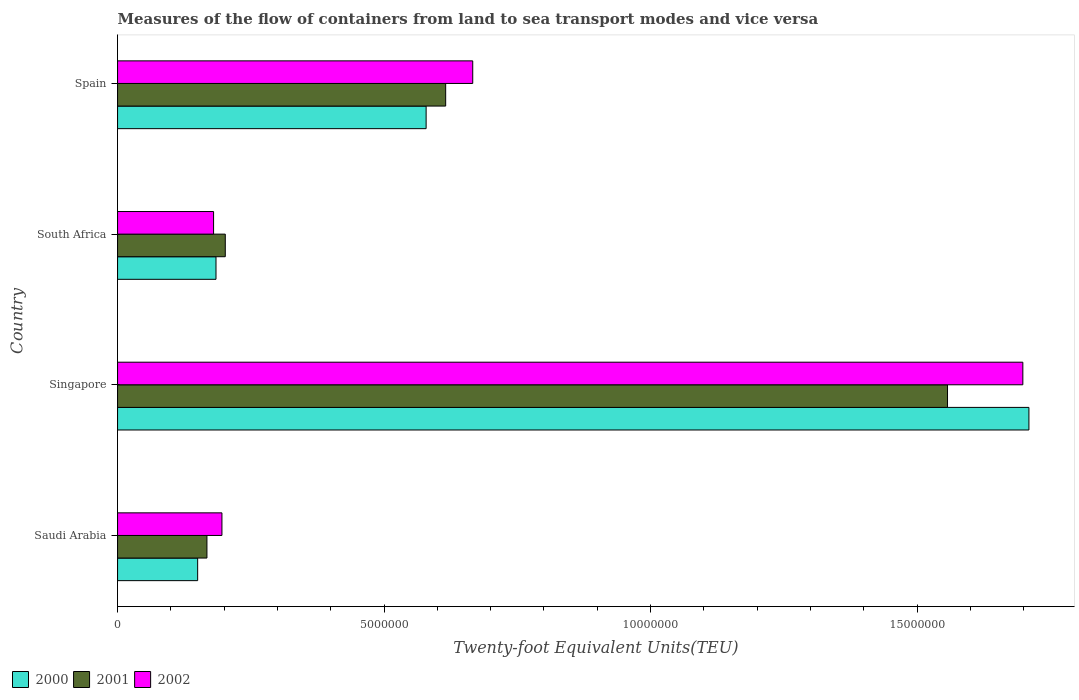How many groups of bars are there?
Make the answer very short. 4. Are the number of bars per tick equal to the number of legend labels?
Your answer should be compact. Yes. Are the number of bars on each tick of the Y-axis equal?
Give a very brief answer. Yes. How many bars are there on the 2nd tick from the top?
Your response must be concise. 3. What is the label of the 4th group of bars from the top?
Provide a succinct answer. Saudi Arabia. In how many cases, is the number of bars for a given country not equal to the number of legend labels?
Offer a terse response. 0. What is the container port traffic in 2000 in Saudi Arabia?
Provide a succinct answer. 1.50e+06. Across all countries, what is the maximum container port traffic in 2002?
Give a very brief answer. 1.70e+07. Across all countries, what is the minimum container port traffic in 2000?
Offer a terse response. 1.50e+06. In which country was the container port traffic in 2000 maximum?
Your response must be concise. Singapore. In which country was the container port traffic in 2001 minimum?
Make the answer very short. Saudi Arabia. What is the total container port traffic in 2002 in the graph?
Make the answer very short. 2.74e+07. What is the difference between the container port traffic in 2000 in Saudi Arabia and that in South Africa?
Ensure brevity in your answer.  -3.44e+05. What is the difference between the container port traffic in 2002 in Saudi Arabia and the container port traffic in 2000 in Singapore?
Keep it short and to the point. -1.51e+07. What is the average container port traffic in 2002 per country?
Your response must be concise. 6.85e+06. What is the difference between the container port traffic in 2002 and container port traffic in 2001 in Singapore?
Your response must be concise. 1.41e+06. What is the ratio of the container port traffic in 2000 in Saudi Arabia to that in South Africa?
Your answer should be very brief. 0.81. Is the container port traffic in 2002 in Singapore less than that in Spain?
Give a very brief answer. No. What is the difference between the highest and the second highest container port traffic in 2000?
Your answer should be compact. 1.13e+07. What is the difference between the highest and the lowest container port traffic in 2001?
Provide a short and direct response. 1.39e+07. In how many countries, is the container port traffic in 2002 greater than the average container port traffic in 2002 taken over all countries?
Make the answer very short. 1. Is the sum of the container port traffic in 2002 in Saudi Arabia and South Africa greater than the maximum container port traffic in 2000 across all countries?
Your response must be concise. No. What does the 3rd bar from the bottom in Spain represents?
Ensure brevity in your answer.  2002. How many bars are there?
Your answer should be very brief. 12. Does the graph contain grids?
Offer a very short reply. No. Where does the legend appear in the graph?
Your answer should be very brief. Bottom left. How many legend labels are there?
Offer a terse response. 3. How are the legend labels stacked?
Your response must be concise. Horizontal. What is the title of the graph?
Your answer should be very brief. Measures of the flow of containers from land to sea transport modes and vice versa. Does "1995" appear as one of the legend labels in the graph?
Give a very brief answer. No. What is the label or title of the X-axis?
Ensure brevity in your answer.  Twenty-foot Equivalent Units(TEU). What is the Twenty-foot Equivalent Units(TEU) of 2000 in Saudi Arabia?
Ensure brevity in your answer.  1.50e+06. What is the Twenty-foot Equivalent Units(TEU) of 2001 in Saudi Arabia?
Offer a very short reply. 1.68e+06. What is the Twenty-foot Equivalent Units(TEU) in 2002 in Saudi Arabia?
Make the answer very short. 1.96e+06. What is the Twenty-foot Equivalent Units(TEU) in 2000 in Singapore?
Give a very brief answer. 1.71e+07. What is the Twenty-foot Equivalent Units(TEU) in 2001 in Singapore?
Your answer should be compact. 1.56e+07. What is the Twenty-foot Equivalent Units(TEU) of 2002 in Singapore?
Provide a short and direct response. 1.70e+07. What is the Twenty-foot Equivalent Units(TEU) in 2000 in South Africa?
Provide a succinct answer. 1.85e+06. What is the Twenty-foot Equivalent Units(TEU) in 2001 in South Africa?
Offer a terse response. 2.02e+06. What is the Twenty-foot Equivalent Units(TEU) in 2002 in South Africa?
Ensure brevity in your answer.  1.80e+06. What is the Twenty-foot Equivalent Units(TEU) of 2000 in Spain?
Ensure brevity in your answer.  5.79e+06. What is the Twenty-foot Equivalent Units(TEU) in 2001 in Spain?
Provide a succinct answer. 6.16e+06. What is the Twenty-foot Equivalent Units(TEU) in 2002 in Spain?
Offer a terse response. 6.66e+06. Across all countries, what is the maximum Twenty-foot Equivalent Units(TEU) of 2000?
Your answer should be very brief. 1.71e+07. Across all countries, what is the maximum Twenty-foot Equivalent Units(TEU) in 2001?
Your answer should be compact. 1.56e+07. Across all countries, what is the maximum Twenty-foot Equivalent Units(TEU) of 2002?
Your answer should be compact. 1.70e+07. Across all countries, what is the minimum Twenty-foot Equivalent Units(TEU) in 2000?
Keep it short and to the point. 1.50e+06. Across all countries, what is the minimum Twenty-foot Equivalent Units(TEU) in 2001?
Provide a succinct answer. 1.68e+06. Across all countries, what is the minimum Twenty-foot Equivalent Units(TEU) in 2002?
Make the answer very short. 1.80e+06. What is the total Twenty-foot Equivalent Units(TEU) of 2000 in the graph?
Your answer should be compact. 2.62e+07. What is the total Twenty-foot Equivalent Units(TEU) in 2001 in the graph?
Ensure brevity in your answer.  2.54e+07. What is the total Twenty-foot Equivalent Units(TEU) in 2002 in the graph?
Offer a terse response. 2.74e+07. What is the difference between the Twenty-foot Equivalent Units(TEU) of 2000 in Saudi Arabia and that in Singapore?
Provide a succinct answer. -1.56e+07. What is the difference between the Twenty-foot Equivalent Units(TEU) of 2001 in Saudi Arabia and that in Singapore?
Offer a very short reply. -1.39e+07. What is the difference between the Twenty-foot Equivalent Units(TEU) in 2002 in Saudi Arabia and that in Singapore?
Your response must be concise. -1.50e+07. What is the difference between the Twenty-foot Equivalent Units(TEU) of 2000 in Saudi Arabia and that in South Africa?
Give a very brief answer. -3.44e+05. What is the difference between the Twenty-foot Equivalent Units(TEU) of 2001 in Saudi Arabia and that in South Africa?
Keep it short and to the point. -3.44e+05. What is the difference between the Twenty-foot Equivalent Units(TEU) of 2002 in Saudi Arabia and that in South Africa?
Your answer should be compact. 1.57e+05. What is the difference between the Twenty-foot Equivalent Units(TEU) in 2000 in Saudi Arabia and that in Spain?
Keep it short and to the point. -4.29e+06. What is the difference between the Twenty-foot Equivalent Units(TEU) of 2001 in Saudi Arabia and that in Spain?
Your answer should be very brief. -4.48e+06. What is the difference between the Twenty-foot Equivalent Units(TEU) of 2002 in Saudi Arabia and that in Spain?
Make the answer very short. -4.71e+06. What is the difference between the Twenty-foot Equivalent Units(TEU) in 2000 in Singapore and that in South Africa?
Offer a terse response. 1.53e+07. What is the difference between the Twenty-foot Equivalent Units(TEU) in 2001 in Singapore and that in South Africa?
Give a very brief answer. 1.36e+07. What is the difference between the Twenty-foot Equivalent Units(TEU) of 2002 in Singapore and that in South Africa?
Offer a terse response. 1.52e+07. What is the difference between the Twenty-foot Equivalent Units(TEU) in 2000 in Singapore and that in Spain?
Make the answer very short. 1.13e+07. What is the difference between the Twenty-foot Equivalent Units(TEU) in 2001 in Singapore and that in Spain?
Offer a terse response. 9.42e+06. What is the difference between the Twenty-foot Equivalent Units(TEU) of 2002 in Singapore and that in Spain?
Provide a short and direct response. 1.03e+07. What is the difference between the Twenty-foot Equivalent Units(TEU) of 2000 in South Africa and that in Spain?
Your answer should be very brief. -3.94e+06. What is the difference between the Twenty-foot Equivalent Units(TEU) in 2001 in South Africa and that in Spain?
Your answer should be very brief. -4.14e+06. What is the difference between the Twenty-foot Equivalent Units(TEU) in 2002 in South Africa and that in Spain?
Offer a terse response. -4.86e+06. What is the difference between the Twenty-foot Equivalent Units(TEU) of 2000 in Saudi Arabia and the Twenty-foot Equivalent Units(TEU) of 2001 in Singapore?
Your response must be concise. -1.41e+07. What is the difference between the Twenty-foot Equivalent Units(TEU) in 2000 in Saudi Arabia and the Twenty-foot Equivalent Units(TEU) in 2002 in Singapore?
Provide a short and direct response. -1.55e+07. What is the difference between the Twenty-foot Equivalent Units(TEU) of 2001 in Saudi Arabia and the Twenty-foot Equivalent Units(TEU) of 2002 in Singapore?
Your response must be concise. -1.53e+07. What is the difference between the Twenty-foot Equivalent Units(TEU) of 2000 in Saudi Arabia and the Twenty-foot Equivalent Units(TEU) of 2001 in South Africa?
Give a very brief answer. -5.18e+05. What is the difference between the Twenty-foot Equivalent Units(TEU) in 2000 in Saudi Arabia and the Twenty-foot Equivalent Units(TEU) in 2002 in South Africa?
Your answer should be compact. -2.99e+05. What is the difference between the Twenty-foot Equivalent Units(TEU) in 2001 in Saudi Arabia and the Twenty-foot Equivalent Units(TEU) in 2002 in South Africa?
Provide a short and direct response. -1.25e+05. What is the difference between the Twenty-foot Equivalent Units(TEU) of 2000 in Saudi Arabia and the Twenty-foot Equivalent Units(TEU) of 2001 in Spain?
Your response must be concise. -4.65e+06. What is the difference between the Twenty-foot Equivalent Units(TEU) of 2000 in Saudi Arabia and the Twenty-foot Equivalent Units(TEU) of 2002 in Spain?
Provide a succinct answer. -5.16e+06. What is the difference between the Twenty-foot Equivalent Units(TEU) of 2001 in Saudi Arabia and the Twenty-foot Equivalent Units(TEU) of 2002 in Spain?
Offer a very short reply. -4.99e+06. What is the difference between the Twenty-foot Equivalent Units(TEU) in 2000 in Singapore and the Twenty-foot Equivalent Units(TEU) in 2001 in South Africa?
Offer a terse response. 1.51e+07. What is the difference between the Twenty-foot Equivalent Units(TEU) of 2000 in Singapore and the Twenty-foot Equivalent Units(TEU) of 2002 in South Africa?
Give a very brief answer. 1.53e+07. What is the difference between the Twenty-foot Equivalent Units(TEU) in 2001 in Singapore and the Twenty-foot Equivalent Units(TEU) in 2002 in South Africa?
Your response must be concise. 1.38e+07. What is the difference between the Twenty-foot Equivalent Units(TEU) in 2000 in Singapore and the Twenty-foot Equivalent Units(TEU) in 2001 in Spain?
Your response must be concise. 1.09e+07. What is the difference between the Twenty-foot Equivalent Units(TEU) of 2000 in Singapore and the Twenty-foot Equivalent Units(TEU) of 2002 in Spain?
Ensure brevity in your answer.  1.04e+07. What is the difference between the Twenty-foot Equivalent Units(TEU) in 2001 in Singapore and the Twenty-foot Equivalent Units(TEU) in 2002 in Spain?
Provide a succinct answer. 8.91e+06. What is the difference between the Twenty-foot Equivalent Units(TEU) in 2000 in South Africa and the Twenty-foot Equivalent Units(TEU) in 2001 in Spain?
Give a very brief answer. -4.31e+06. What is the difference between the Twenty-foot Equivalent Units(TEU) of 2000 in South Africa and the Twenty-foot Equivalent Units(TEU) of 2002 in Spain?
Ensure brevity in your answer.  -4.82e+06. What is the difference between the Twenty-foot Equivalent Units(TEU) of 2001 in South Africa and the Twenty-foot Equivalent Units(TEU) of 2002 in Spain?
Give a very brief answer. -4.64e+06. What is the average Twenty-foot Equivalent Units(TEU) of 2000 per country?
Offer a very short reply. 6.56e+06. What is the average Twenty-foot Equivalent Units(TEU) of 2001 per country?
Make the answer very short. 6.36e+06. What is the average Twenty-foot Equivalent Units(TEU) of 2002 per country?
Give a very brief answer. 6.85e+06. What is the difference between the Twenty-foot Equivalent Units(TEU) of 2000 and Twenty-foot Equivalent Units(TEU) of 2001 in Saudi Arabia?
Offer a very short reply. -1.74e+05. What is the difference between the Twenty-foot Equivalent Units(TEU) of 2000 and Twenty-foot Equivalent Units(TEU) of 2002 in Saudi Arabia?
Provide a short and direct response. -4.56e+05. What is the difference between the Twenty-foot Equivalent Units(TEU) in 2001 and Twenty-foot Equivalent Units(TEU) in 2002 in Saudi Arabia?
Give a very brief answer. -2.82e+05. What is the difference between the Twenty-foot Equivalent Units(TEU) of 2000 and Twenty-foot Equivalent Units(TEU) of 2001 in Singapore?
Your answer should be compact. 1.53e+06. What is the difference between the Twenty-foot Equivalent Units(TEU) of 2000 and Twenty-foot Equivalent Units(TEU) of 2002 in Singapore?
Offer a very short reply. 1.14e+05. What is the difference between the Twenty-foot Equivalent Units(TEU) of 2001 and Twenty-foot Equivalent Units(TEU) of 2002 in Singapore?
Your response must be concise. -1.41e+06. What is the difference between the Twenty-foot Equivalent Units(TEU) of 2000 and Twenty-foot Equivalent Units(TEU) of 2001 in South Africa?
Offer a very short reply. -1.74e+05. What is the difference between the Twenty-foot Equivalent Units(TEU) of 2000 and Twenty-foot Equivalent Units(TEU) of 2002 in South Africa?
Provide a succinct answer. 4.53e+04. What is the difference between the Twenty-foot Equivalent Units(TEU) in 2001 and Twenty-foot Equivalent Units(TEU) in 2002 in South Africa?
Keep it short and to the point. 2.20e+05. What is the difference between the Twenty-foot Equivalent Units(TEU) of 2000 and Twenty-foot Equivalent Units(TEU) of 2001 in Spain?
Your response must be concise. -3.67e+05. What is the difference between the Twenty-foot Equivalent Units(TEU) of 2000 and Twenty-foot Equivalent Units(TEU) of 2002 in Spain?
Offer a terse response. -8.74e+05. What is the difference between the Twenty-foot Equivalent Units(TEU) of 2001 and Twenty-foot Equivalent Units(TEU) of 2002 in Spain?
Your response must be concise. -5.08e+05. What is the ratio of the Twenty-foot Equivalent Units(TEU) in 2000 in Saudi Arabia to that in Singapore?
Make the answer very short. 0.09. What is the ratio of the Twenty-foot Equivalent Units(TEU) of 2001 in Saudi Arabia to that in Singapore?
Give a very brief answer. 0.11. What is the ratio of the Twenty-foot Equivalent Units(TEU) of 2002 in Saudi Arabia to that in Singapore?
Make the answer very short. 0.12. What is the ratio of the Twenty-foot Equivalent Units(TEU) in 2000 in Saudi Arabia to that in South Africa?
Your answer should be very brief. 0.81. What is the ratio of the Twenty-foot Equivalent Units(TEU) in 2001 in Saudi Arabia to that in South Africa?
Your response must be concise. 0.83. What is the ratio of the Twenty-foot Equivalent Units(TEU) of 2002 in Saudi Arabia to that in South Africa?
Your answer should be compact. 1.09. What is the ratio of the Twenty-foot Equivalent Units(TEU) of 2000 in Saudi Arabia to that in Spain?
Keep it short and to the point. 0.26. What is the ratio of the Twenty-foot Equivalent Units(TEU) of 2001 in Saudi Arabia to that in Spain?
Your answer should be very brief. 0.27. What is the ratio of the Twenty-foot Equivalent Units(TEU) in 2002 in Saudi Arabia to that in Spain?
Your response must be concise. 0.29. What is the ratio of the Twenty-foot Equivalent Units(TEU) in 2000 in Singapore to that in South Africa?
Make the answer very short. 9.26. What is the ratio of the Twenty-foot Equivalent Units(TEU) of 2001 in Singapore to that in South Africa?
Your answer should be very brief. 7.7. What is the ratio of the Twenty-foot Equivalent Units(TEU) in 2002 in Singapore to that in South Africa?
Ensure brevity in your answer.  9.43. What is the ratio of the Twenty-foot Equivalent Units(TEU) of 2000 in Singapore to that in Spain?
Ensure brevity in your answer.  2.95. What is the ratio of the Twenty-foot Equivalent Units(TEU) in 2001 in Singapore to that in Spain?
Your response must be concise. 2.53. What is the ratio of the Twenty-foot Equivalent Units(TEU) in 2002 in Singapore to that in Spain?
Make the answer very short. 2.55. What is the ratio of the Twenty-foot Equivalent Units(TEU) of 2000 in South Africa to that in Spain?
Your response must be concise. 0.32. What is the ratio of the Twenty-foot Equivalent Units(TEU) in 2001 in South Africa to that in Spain?
Keep it short and to the point. 0.33. What is the ratio of the Twenty-foot Equivalent Units(TEU) of 2002 in South Africa to that in Spain?
Give a very brief answer. 0.27. What is the difference between the highest and the second highest Twenty-foot Equivalent Units(TEU) of 2000?
Keep it short and to the point. 1.13e+07. What is the difference between the highest and the second highest Twenty-foot Equivalent Units(TEU) of 2001?
Provide a succinct answer. 9.42e+06. What is the difference between the highest and the second highest Twenty-foot Equivalent Units(TEU) of 2002?
Offer a terse response. 1.03e+07. What is the difference between the highest and the lowest Twenty-foot Equivalent Units(TEU) in 2000?
Provide a succinct answer. 1.56e+07. What is the difference between the highest and the lowest Twenty-foot Equivalent Units(TEU) in 2001?
Provide a succinct answer. 1.39e+07. What is the difference between the highest and the lowest Twenty-foot Equivalent Units(TEU) of 2002?
Offer a very short reply. 1.52e+07. 